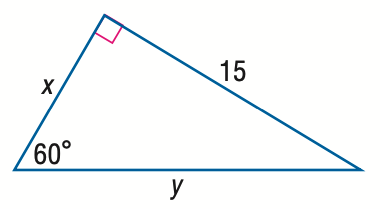Answer the mathemtical geometry problem and directly provide the correct option letter.
Question: Find x.
Choices: A: 5 \sqrt { 3 } B: 15 C: 15 \sqrt { 3 } D: 30 A 